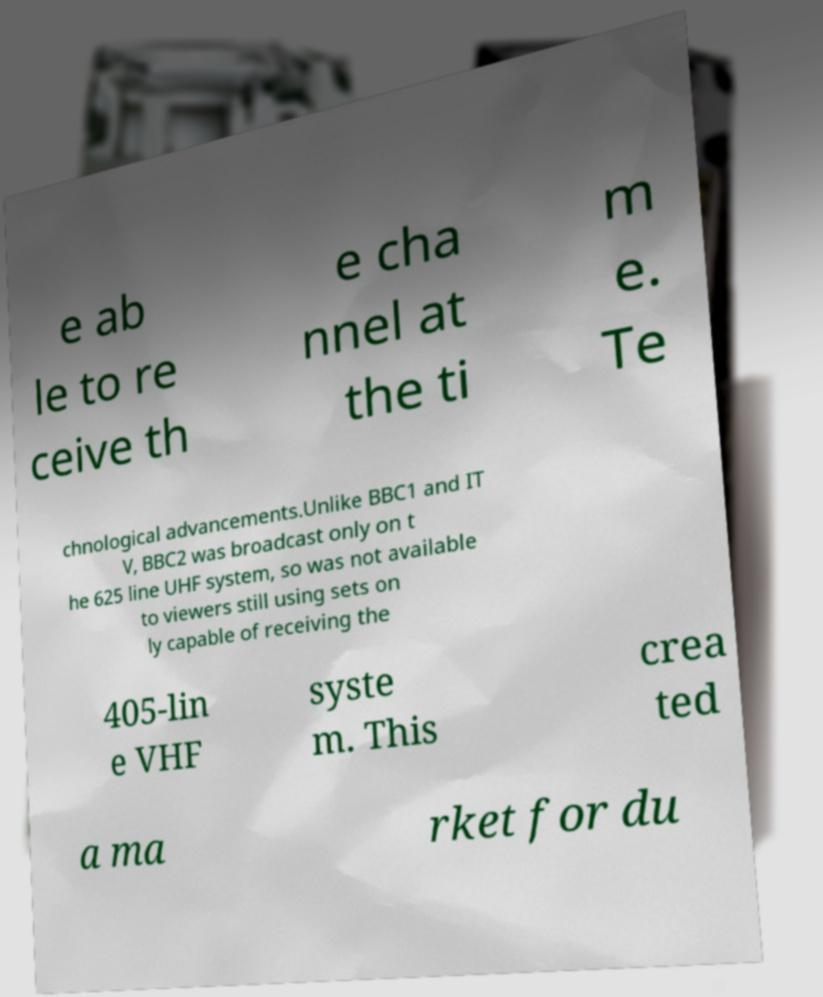Can you read and provide the text displayed in the image?This photo seems to have some interesting text. Can you extract and type it out for me? e ab le to re ceive th e cha nnel at the ti m e. Te chnological advancements.Unlike BBC1 and IT V, BBC2 was broadcast only on t he 625 line UHF system, so was not available to viewers still using sets on ly capable of receiving the 405-lin e VHF syste m. This crea ted a ma rket for du 